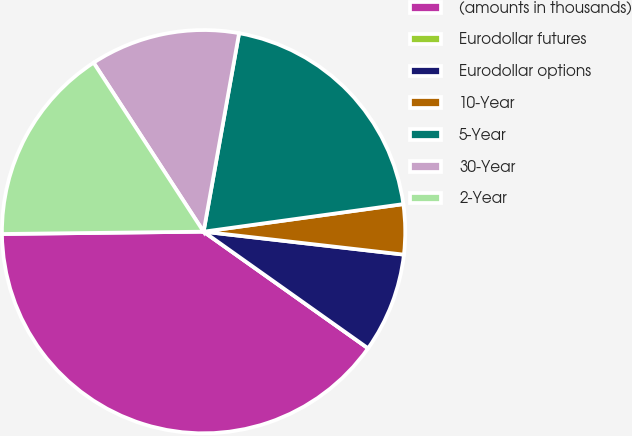Convert chart. <chart><loc_0><loc_0><loc_500><loc_500><pie_chart><fcel>(amounts in thousands)<fcel>Eurodollar futures<fcel>Eurodollar options<fcel>10-Year<fcel>5-Year<fcel>30-Year<fcel>2-Year<nl><fcel>40.0%<fcel>0.0%<fcel>8.0%<fcel>4.0%<fcel>20.0%<fcel>12.0%<fcel>16.0%<nl></chart> 